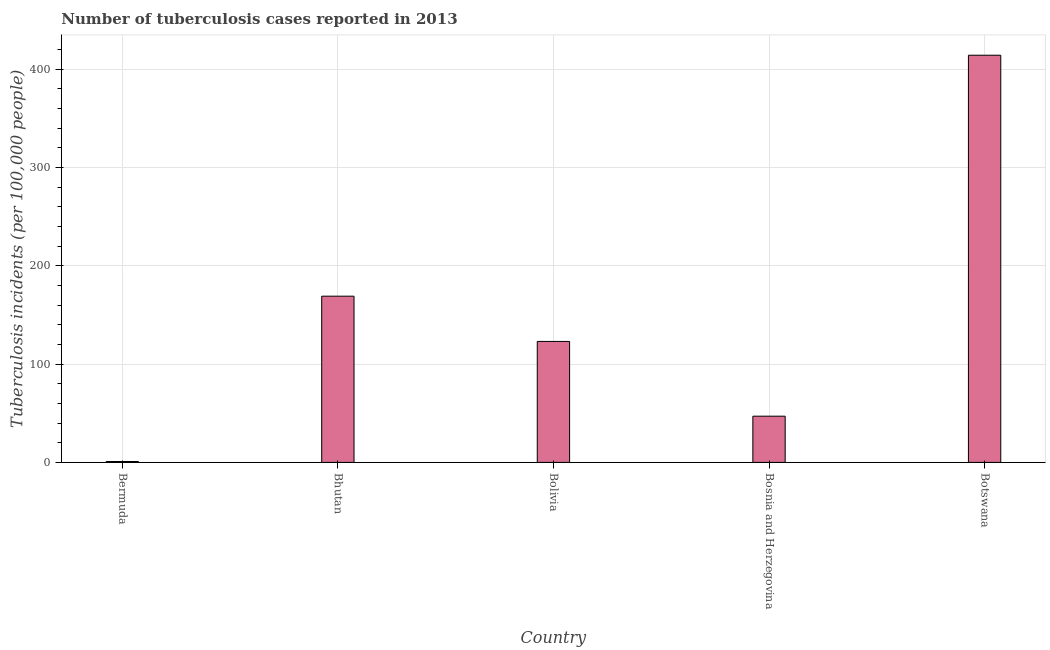What is the title of the graph?
Offer a very short reply. Number of tuberculosis cases reported in 2013. What is the label or title of the Y-axis?
Your answer should be compact. Tuberculosis incidents (per 100,0 people). Across all countries, what is the maximum number of tuberculosis incidents?
Provide a short and direct response. 414. Across all countries, what is the minimum number of tuberculosis incidents?
Make the answer very short. 0.9. In which country was the number of tuberculosis incidents maximum?
Make the answer very short. Botswana. In which country was the number of tuberculosis incidents minimum?
Provide a succinct answer. Bermuda. What is the sum of the number of tuberculosis incidents?
Provide a succinct answer. 753.9. What is the difference between the number of tuberculosis incidents in Bolivia and Botswana?
Keep it short and to the point. -291. What is the average number of tuberculosis incidents per country?
Offer a terse response. 150.78. What is the median number of tuberculosis incidents?
Keep it short and to the point. 123. What is the ratio of the number of tuberculosis incidents in Bermuda to that in Bolivia?
Offer a terse response. 0.01. What is the difference between the highest and the second highest number of tuberculosis incidents?
Offer a very short reply. 245. Is the sum of the number of tuberculosis incidents in Bermuda and Bhutan greater than the maximum number of tuberculosis incidents across all countries?
Provide a short and direct response. No. What is the difference between the highest and the lowest number of tuberculosis incidents?
Provide a short and direct response. 413.1. How many bars are there?
Provide a succinct answer. 5. Are all the bars in the graph horizontal?
Offer a very short reply. No. Are the values on the major ticks of Y-axis written in scientific E-notation?
Provide a short and direct response. No. What is the Tuberculosis incidents (per 100,000 people) in Bhutan?
Keep it short and to the point. 169. What is the Tuberculosis incidents (per 100,000 people) in Bolivia?
Offer a very short reply. 123. What is the Tuberculosis incidents (per 100,000 people) of Botswana?
Provide a succinct answer. 414. What is the difference between the Tuberculosis incidents (per 100,000 people) in Bermuda and Bhutan?
Provide a succinct answer. -168.1. What is the difference between the Tuberculosis incidents (per 100,000 people) in Bermuda and Bolivia?
Make the answer very short. -122.1. What is the difference between the Tuberculosis incidents (per 100,000 people) in Bermuda and Bosnia and Herzegovina?
Ensure brevity in your answer.  -46.1. What is the difference between the Tuberculosis incidents (per 100,000 people) in Bermuda and Botswana?
Your response must be concise. -413.1. What is the difference between the Tuberculosis incidents (per 100,000 people) in Bhutan and Bolivia?
Your answer should be compact. 46. What is the difference between the Tuberculosis incidents (per 100,000 people) in Bhutan and Bosnia and Herzegovina?
Give a very brief answer. 122. What is the difference between the Tuberculosis incidents (per 100,000 people) in Bhutan and Botswana?
Offer a very short reply. -245. What is the difference between the Tuberculosis incidents (per 100,000 people) in Bolivia and Bosnia and Herzegovina?
Provide a succinct answer. 76. What is the difference between the Tuberculosis incidents (per 100,000 people) in Bolivia and Botswana?
Keep it short and to the point. -291. What is the difference between the Tuberculosis incidents (per 100,000 people) in Bosnia and Herzegovina and Botswana?
Give a very brief answer. -367. What is the ratio of the Tuberculosis incidents (per 100,000 people) in Bermuda to that in Bhutan?
Provide a succinct answer. 0.01. What is the ratio of the Tuberculosis incidents (per 100,000 people) in Bermuda to that in Bolivia?
Your answer should be compact. 0.01. What is the ratio of the Tuberculosis incidents (per 100,000 people) in Bermuda to that in Bosnia and Herzegovina?
Provide a succinct answer. 0.02. What is the ratio of the Tuberculosis incidents (per 100,000 people) in Bermuda to that in Botswana?
Provide a short and direct response. 0. What is the ratio of the Tuberculosis incidents (per 100,000 people) in Bhutan to that in Bolivia?
Make the answer very short. 1.37. What is the ratio of the Tuberculosis incidents (per 100,000 people) in Bhutan to that in Bosnia and Herzegovina?
Your answer should be compact. 3.6. What is the ratio of the Tuberculosis incidents (per 100,000 people) in Bhutan to that in Botswana?
Ensure brevity in your answer.  0.41. What is the ratio of the Tuberculosis incidents (per 100,000 people) in Bolivia to that in Bosnia and Herzegovina?
Your answer should be compact. 2.62. What is the ratio of the Tuberculosis incidents (per 100,000 people) in Bolivia to that in Botswana?
Provide a short and direct response. 0.3. What is the ratio of the Tuberculosis incidents (per 100,000 people) in Bosnia and Herzegovina to that in Botswana?
Keep it short and to the point. 0.11. 